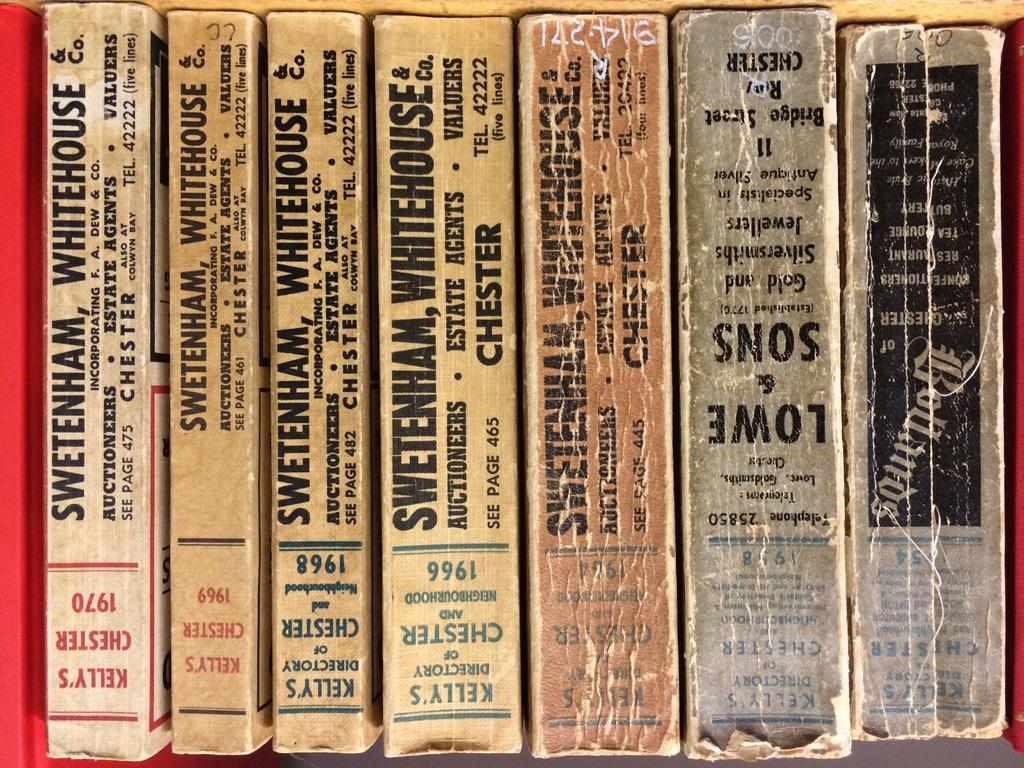<image>
Write a terse but informative summary of the picture. Seven books but five of them are by Swetenham Whitehouse 